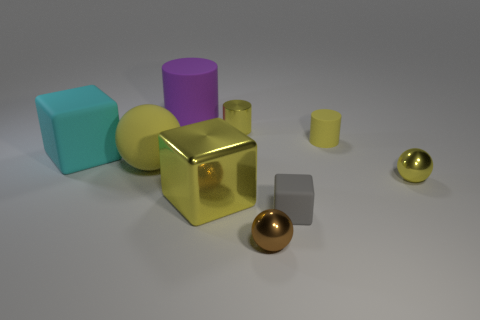What can be said about the composition and balance of the objects in this image? The composition is carefully balanced, with objects of varying shapes, sizes, and colors arranged to create a harmonious yet dynamic scene. The different textures and reflections also add visual interest and depth to the composition. Do the objects follow any particular theme or pattern? The objects do not seem to follow a specific thematic pattern but are more an assembly of geometric shapes. Their arrangement and diversity in appearances could represent diversity in unity, or merely a non-representational study in form and color. 